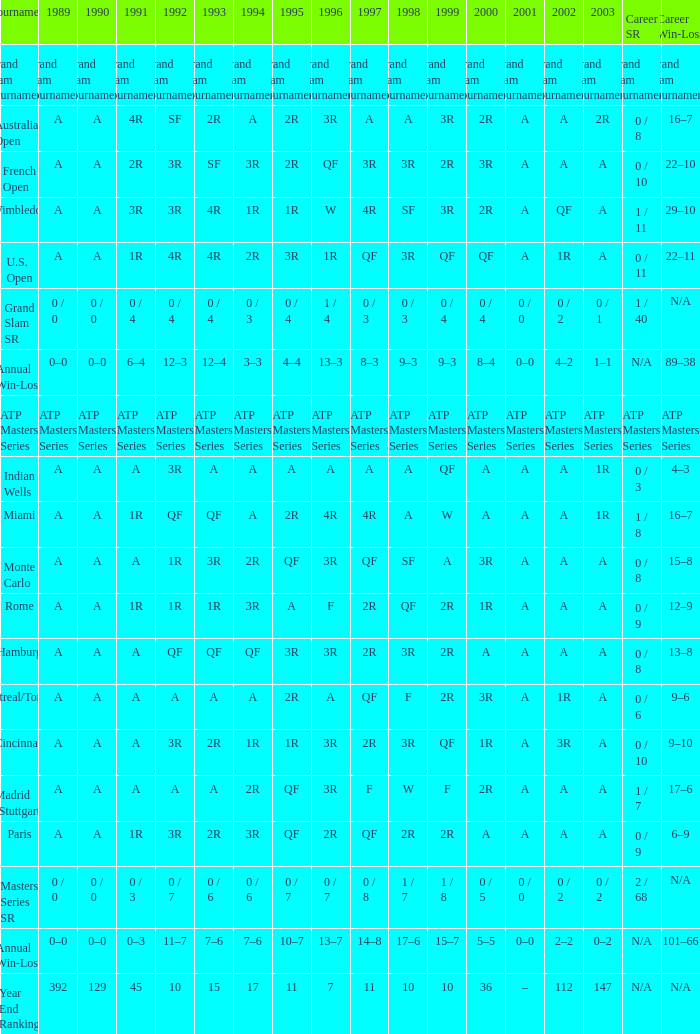In 1997, what was the value if 2002 was denoted by a and 2003 by 1r? A, 4R. 